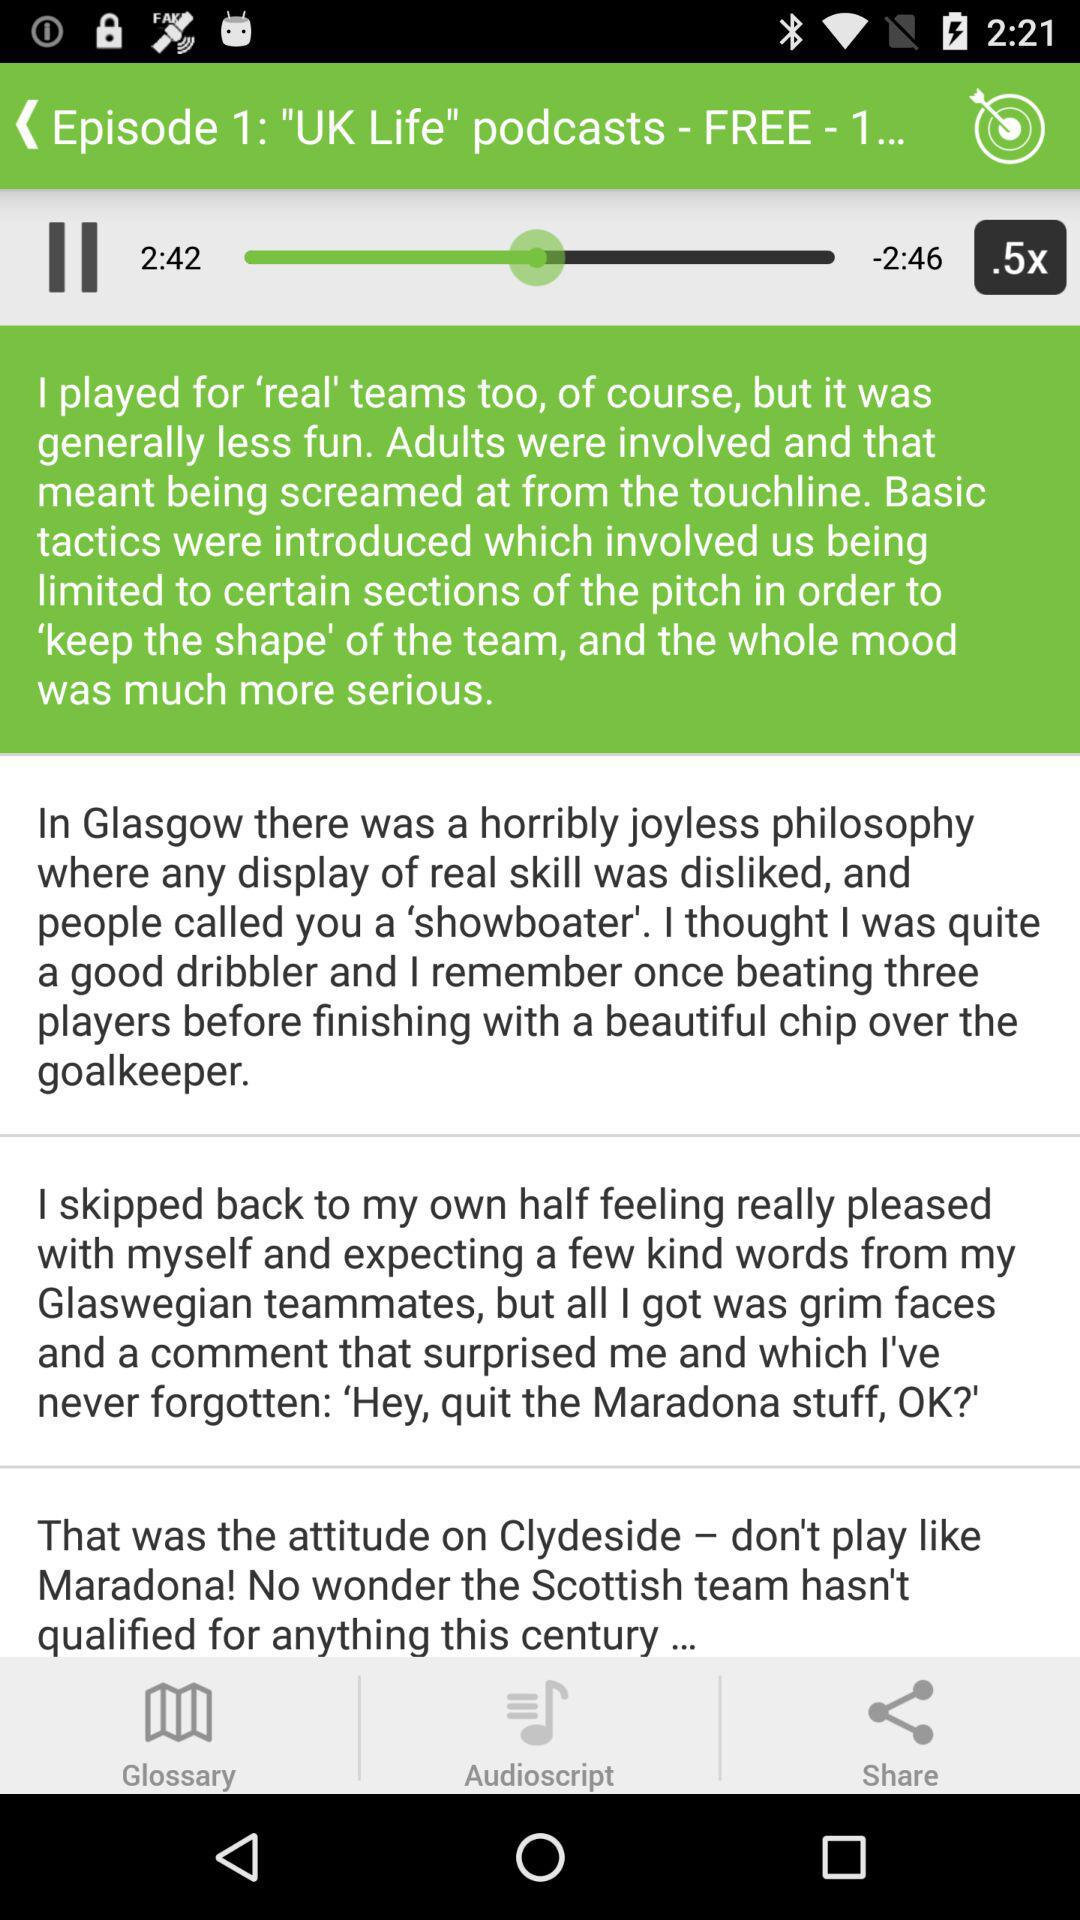What is the given level? The given level is "Intermediate, Advanced". 